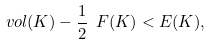Convert formula to latex. <formula><loc_0><loc_0><loc_500><loc_500>\ v o l ( K ) - \frac { 1 } { 2 } \ F ( K ) < \L E ( K ) ,</formula> 